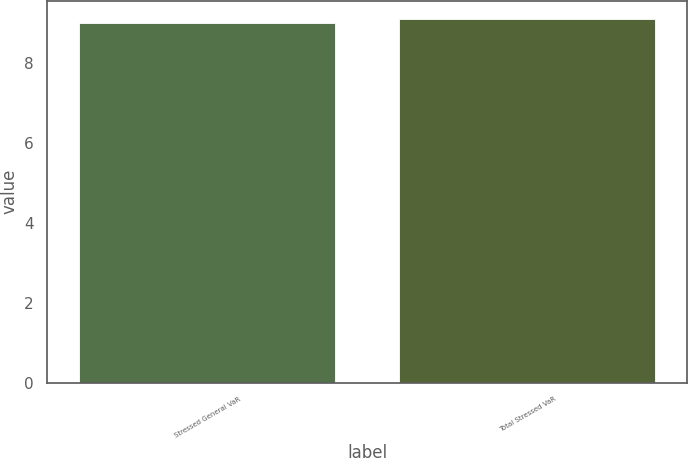<chart> <loc_0><loc_0><loc_500><loc_500><bar_chart><fcel>Stressed General VaR<fcel>Total Stressed VaR<nl><fcel>9<fcel>9.1<nl></chart> 